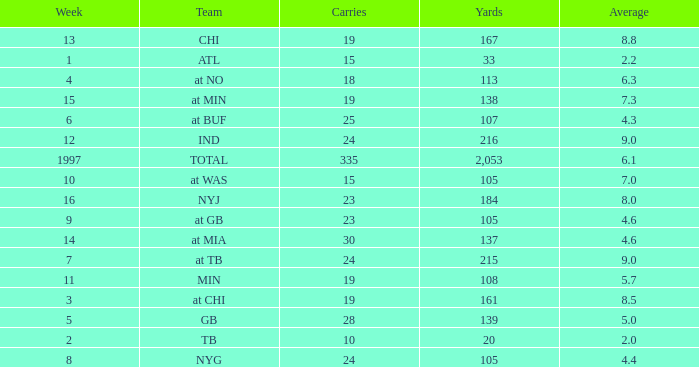Which Team has 19 Carries, and a Week larger than 13? At min. 